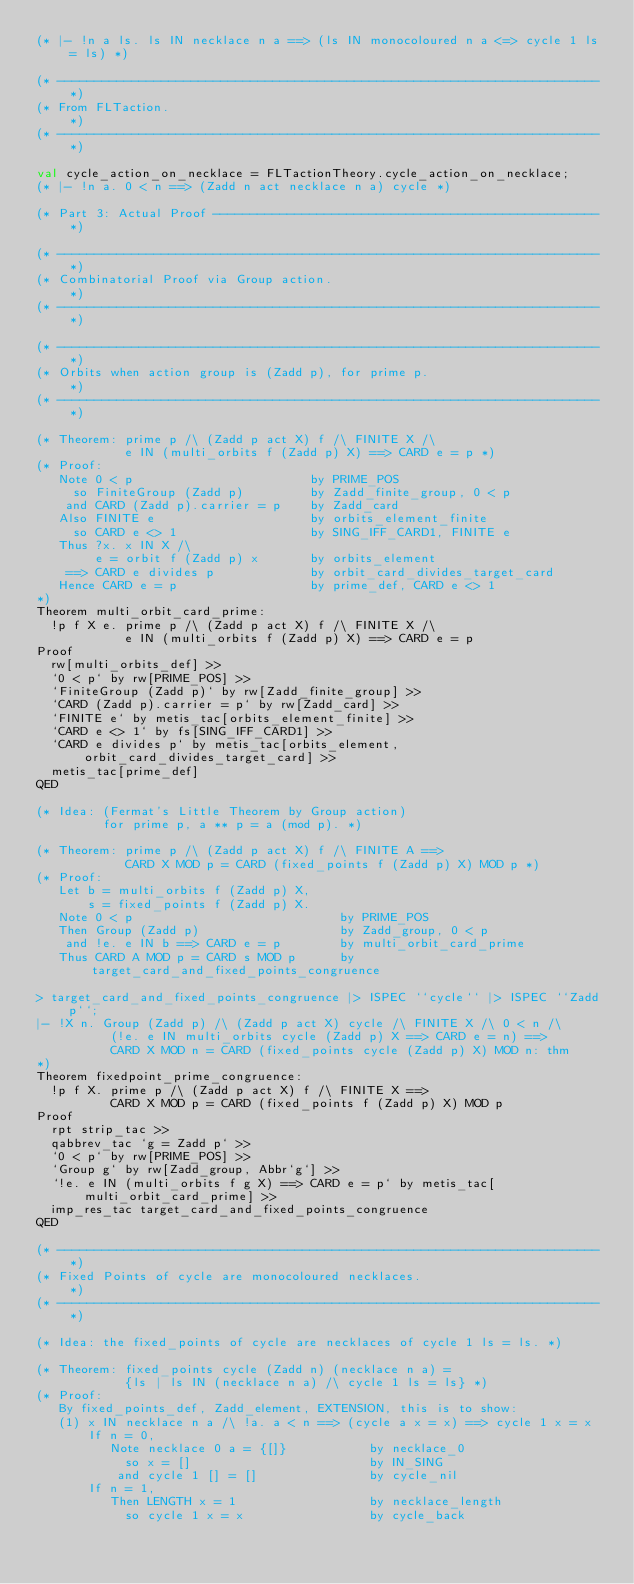<code> <loc_0><loc_0><loc_500><loc_500><_SML_>(* |- !n a ls. ls IN necklace n a ==> (ls IN monocoloured n a <=> cycle 1 ls = ls) *)

(* ------------------------------------------------------------------------- *)
(* From FLTaction.                                                           *)
(* ------------------------------------------------------------------------- *)

val cycle_action_on_necklace = FLTactionTheory.cycle_action_on_necklace;
(* |- !n a. 0 < n ==> (Zadd n act necklace n a) cycle *)

(* Part 3: Actual Proof ---------------------------------------------------- *)

(* ------------------------------------------------------------------------- *)
(* Combinatorial Proof via Group action.                                     *)
(* ------------------------------------------------------------------------- *)

(* ------------------------------------------------------------------------- *)
(* Orbits when action group is (Zadd p), for prime p.                        *)
(* ------------------------------------------------------------------------- *)

(* Theorem: prime p /\ (Zadd p act X) f /\ FINITE X /\
            e IN (multi_orbits f (Zadd p) X) ==> CARD e = p *)
(* Proof:
   Note 0 < p                        by PRIME_POS
     so FiniteGroup (Zadd p)         by Zadd_finite_group, 0 < p
    and CARD (Zadd p).carrier = p    by Zadd_card
   Also FINITE e                     by orbits_element_finite
     so CARD e <> 1                  by SING_IFF_CARD1, FINITE e
   Thus ?x. x IN X /\
        e = orbit f (Zadd p) x       by orbits_element
    ==> CARD e divides p             by orbit_card_divides_target_card
   Hence CARD e = p                  by prime_def, CARD e <> 1
*)
Theorem multi_orbit_card_prime:
  !p f X e. prime p /\ (Zadd p act X) f /\ FINITE X /\
            e IN (multi_orbits f (Zadd p) X) ==> CARD e = p
Proof
  rw[multi_orbits_def] >>
  `0 < p` by rw[PRIME_POS] >>
  `FiniteGroup (Zadd p)` by rw[Zadd_finite_group] >>
  `CARD (Zadd p).carrier = p` by rw[Zadd_card] >>
  `FINITE e` by metis_tac[orbits_element_finite] >>
  `CARD e <> 1` by fs[SING_IFF_CARD1] >>
  `CARD e divides p` by metis_tac[orbits_element, orbit_card_divides_target_card] >>
  metis_tac[prime_def]
QED

(* Idea: (Fermat's Little Theorem by Group action)
         for prime p, a ** p = a (mod p). *)

(* Theorem: prime p /\ (Zadd p act X) f /\ FINITE A ==>
            CARD X MOD p = CARD (fixed_points f (Zadd p) X) MOD p *)
(* Proof:
   Let b = multi_orbits f (Zadd p) X,
       s = fixed_points f (Zadd p) X.
   Note 0 < p                            by PRIME_POS
   Then Group (Zadd p)                   by Zadd_group, 0 < p
    and !e. e IN b ==> CARD e = p        by multi_orbit_card_prime
   Thus CARD A MOD p = CARD s MOD p      by target_card_and_fixed_points_congruence

> target_card_and_fixed_points_congruence |> ISPEC ``cycle`` |> ISPEC ``Zadd p``;
|- !X n. Group (Zadd p) /\ (Zadd p act X) cycle /\ FINITE X /\ 0 < n /\
          (!e. e IN multi_orbits cycle (Zadd p) X ==> CARD e = n) ==>
          CARD X MOD n = CARD (fixed_points cycle (Zadd p) X) MOD n: thm
*)
Theorem fixedpoint_prime_congruence:
  !p f X. prime p /\ (Zadd p act X) f /\ FINITE X ==>
          CARD X MOD p = CARD (fixed_points f (Zadd p) X) MOD p
Proof
  rpt strip_tac >>
  qabbrev_tac `g = Zadd p` >>
  `0 < p` by rw[PRIME_POS] >>
  `Group g` by rw[Zadd_group, Abbr`g`] >>
  `!e. e IN (multi_orbits f g X) ==> CARD e = p` by metis_tac[multi_orbit_card_prime] >>
  imp_res_tac target_card_and_fixed_points_congruence
QED

(* ------------------------------------------------------------------------- *)
(* Fixed Points of cycle are monocoloured necklaces.                         *)
(* ------------------------------------------------------------------------- *)

(* Idea: the fixed_points of cycle are necklaces of cycle 1 ls = ls. *)

(* Theorem: fixed_points cycle (Zadd n) (necklace n a) =
            {ls | ls IN (necklace n a) /\ cycle 1 ls = ls} *)
(* Proof:
   By fixed_points_def, Zadd_element, EXTENSION, this is to show:
   (1) x IN necklace n a /\ !a. a < n ==> (cycle a x = x) ==> cycle 1 x = x
       If n = 0,
          Note necklace 0 a = {[]}           by necklace_0
            so x = []                        by IN_SING
           and cycle 1 [] = []               by cycle_nil
       If n = 1,
          Then LENGTH x = 1                  by necklace_length
            so cycle 1 x = x                 by cycle_back</code> 